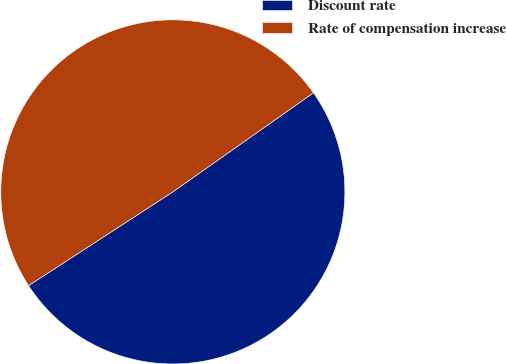Convert chart. <chart><loc_0><loc_0><loc_500><loc_500><pie_chart><fcel>Discount rate<fcel>Rate of compensation increase<nl><fcel>50.6%<fcel>49.4%<nl></chart> 